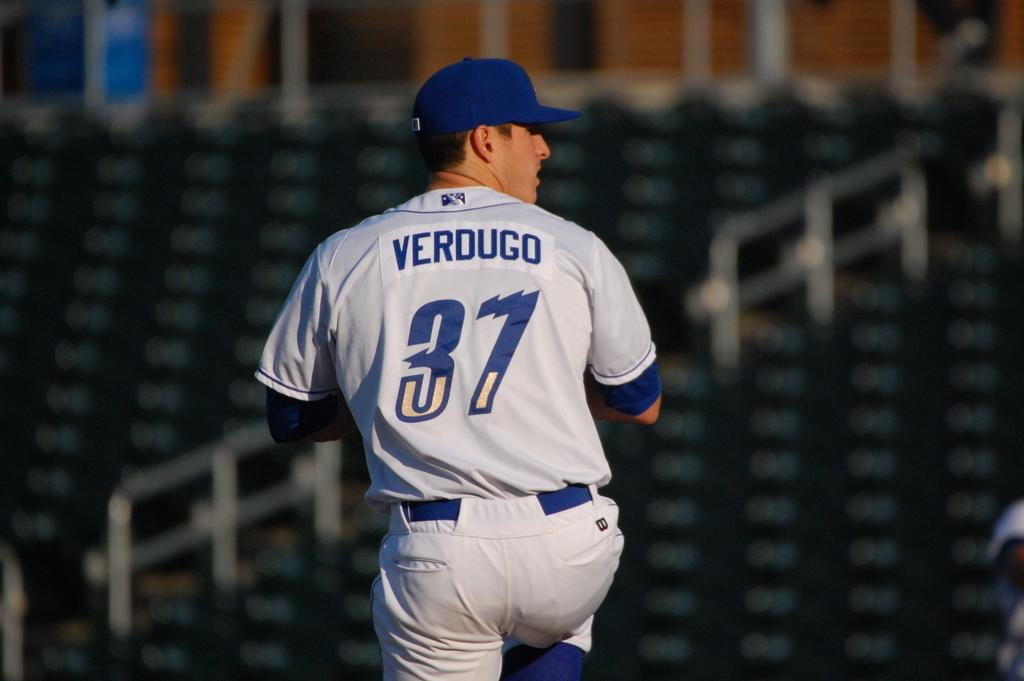<image>
Render a clear and concise summary of the photo. At any empty stadium, a picture with the name Verdugo and the number 37 on his jersey is getting ready to pitch. 